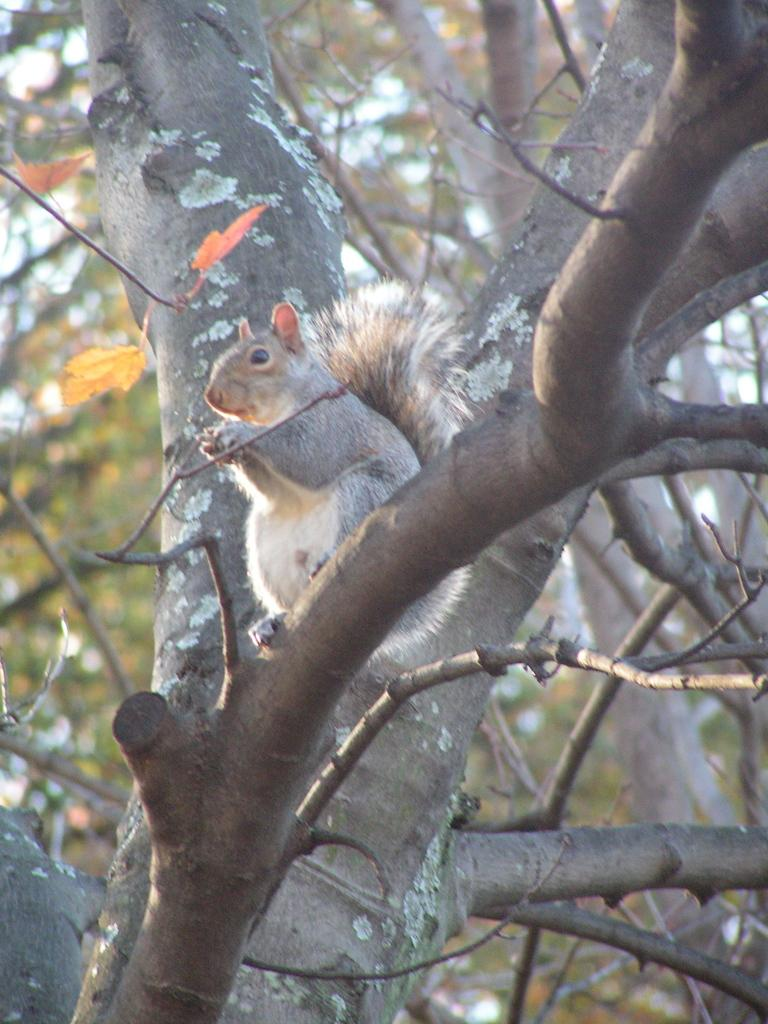What is the main subject in the image? There is a tree in the image. Can you describe the activity of the animal in the image? A squirrel is sitting on a branch of the tree. What type of music can be heard coming from the library in the image? There is no library or music present in the image; it features a tree with a squirrel sitting on a branch. 